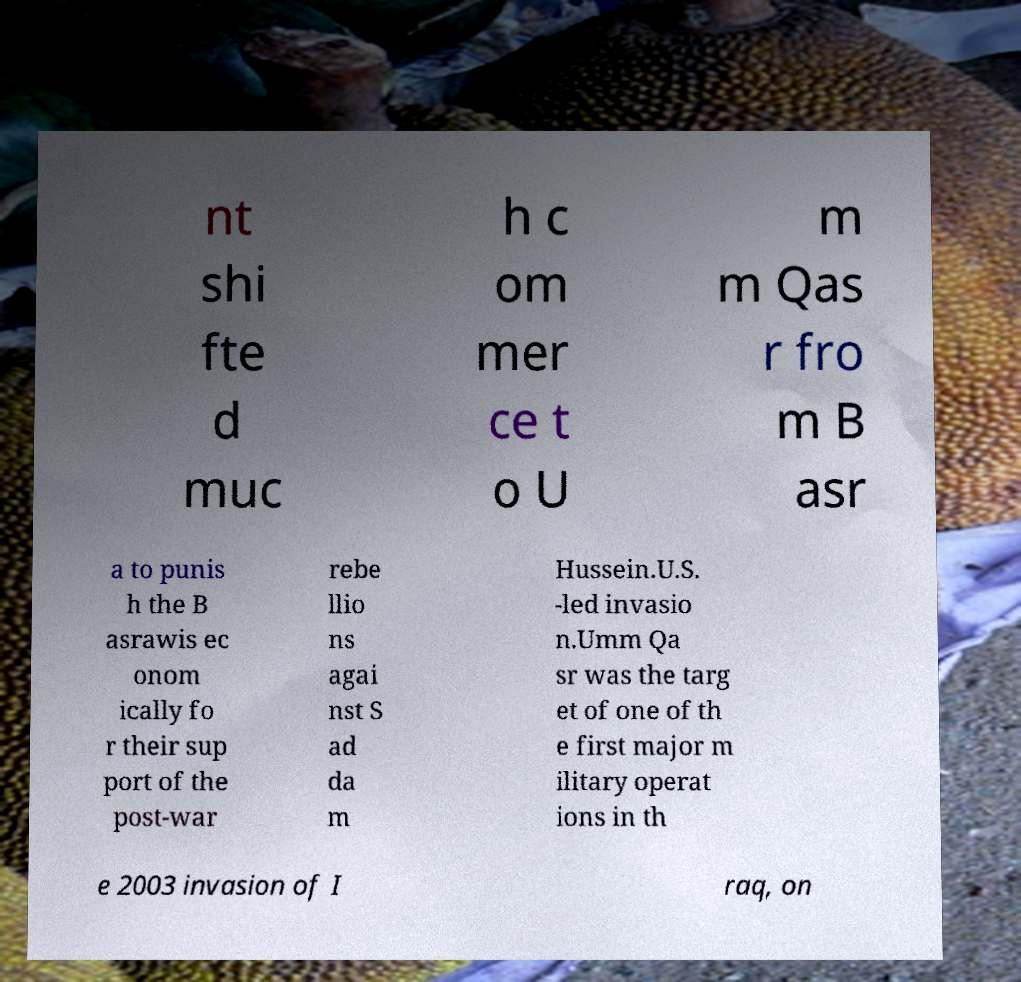For documentation purposes, I need the text within this image transcribed. Could you provide that? nt shi fte d muc h c om mer ce t o U m m Qas r fro m B asr a to punis h the B asrawis ec onom ically fo r their sup port of the post-war rebe llio ns agai nst S ad da m Hussein.U.S. -led invasio n.Umm Qa sr was the targ et of one of th e first major m ilitary operat ions in th e 2003 invasion of I raq, on 